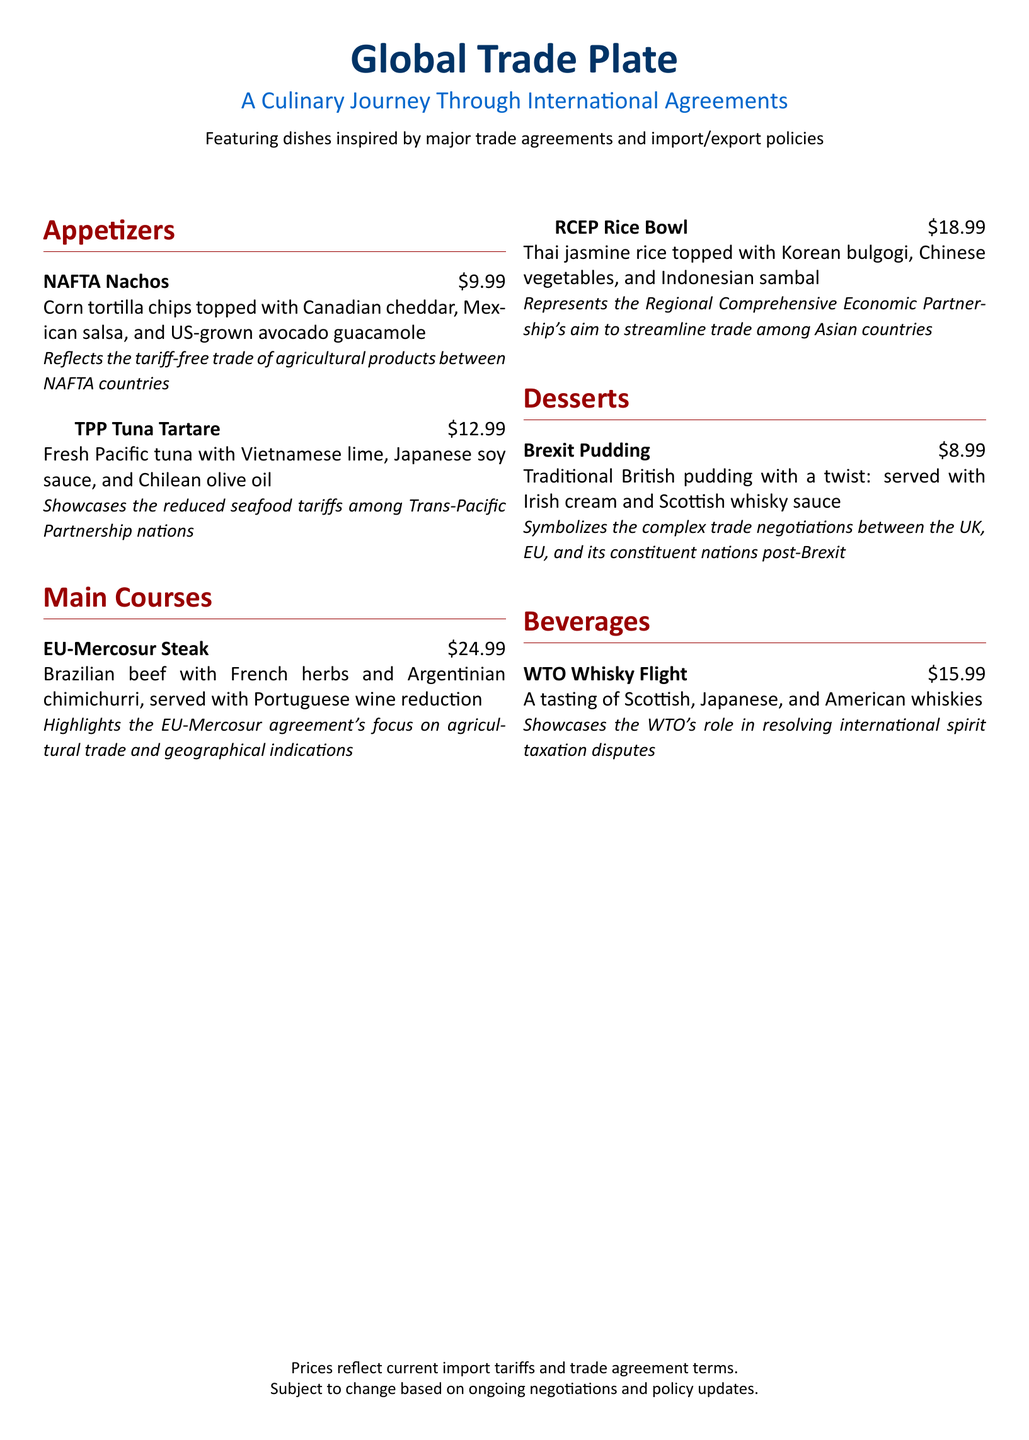What is the price of NAFTA Nachos? The price of NAFTA Nachos is listed directly under the dish name in the menu.
Answer: $9.99 What do TPP Tuna Tartare ingredients include? The ingredients are specifically mentioned alongside the dish name, highlighting its international flavor profile.
Answer: Fresh Pacific tuna, Vietnamese lime, Japanese soy sauce, Chilean olive oil Which trade agreement does the EU-Mercosur Steak represent? The menu explicitly states the dish relates to the EU-Mercosur agreement.
Answer: EU-Mercosur What region does the RCEP Rice Bowl represent? The menu describes the RCEP Rice Bowl and links it to its related trade partnership, mentioning countries involved.
Answer: Asia What flavor is the Brexit Pudding served with? The menu details the flavor pairings for the dessert, indicating its unique characteristics.
Answer: Irish cream and Scottish whisky sauce How much does the WTO Whisky Flight cost? The price is given next to the dish name and reflects its premium offerings.
Answer: $15.99 What is the significance of the NAFTA Nachos? The menu explains the dish's meaning in terms of trade policies and agreements.
Answer: Tariff-free trade of agricultural products How many appetizers are listed in the menu? The document provides a structured overview, indicating how many appetizers are available.
Answer: 2 What additional information is provided about pricing? The menu includes a note about pricing factors that may affect changes.
Answer: Subject to change based on ongoing negotiations and policy updates 